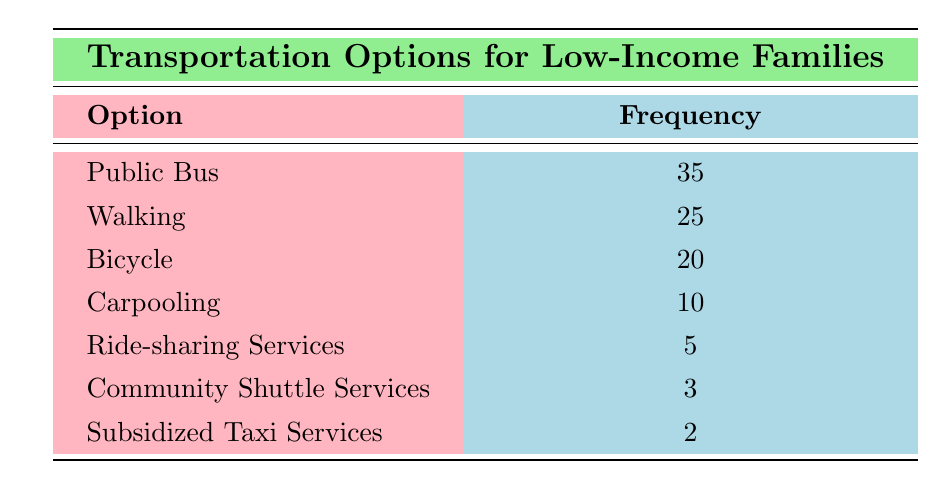What is the most common transportation option for low-income families? The table lists various transportation options along with their frequencies. The option with the highest frequency is "Public Bus," which has a frequency of 35.
Answer: Public Bus How many more families use bicycles than ride-sharing services? To find this, we look at the frequencies for "Bicycle" (20) and "Ride-sharing Services" (5). The difference is 20 - 5 = 15.
Answer: 15 Is the frequency of carpooling higher than that of community shuttle services? The frequency for "Carpooling" is 10, while for "Community Shuttle Services," it is 3. Since 10 is greater than 3, the statement is true.
Answer: Yes What is the total frequency of all transportation options listed? We sum the frequencies of all options: 35 (Public Bus) + 25 (Walking) + 20 (Bicycle) + 10 (Carpooling) + 5 (Ride-sharing Services) + 2 (Subsidized Taxi Services) + 3 (Community Shuttle Services) = 100.
Answer: 100 Which transportation option has the lowest frequency? By reviewing the table, the option with the lowest frequency is "Subsidized Taxi Services" with a frequency of 2.
Answer: Subsidized Taxi Services What is the average frequency of transportation options available? There are 7 transportation options listed, and their total frequency is 100. To find the average, we divide the total frequency by the number of options: 100 / 7 ≈ 14.29.
Answer: Approximately 14.29 Do more families prefer walking over using ride-sharing services? The frequency for "Walking" is 25, while for "Ride-sharing Services," it is 5. Since 25 is greater than 5, yes, more families prefer walking.
Answer: Yes If you combine the frequencies of carpooling and bicycle usage, how does it compare to public bus usage? The combined frequency of "Carpooling" (10) and "Bicycle" (20) is 10 + 20 = 30, which is less than the frequency of "Public Bus" (35).
Answer: Less than How many transportation options have a frequency of less than 10? We can see that "Ride-sharing Services" (5), "Community Shuttle Services" (3), and "Subsidized Taxi Services" (2) all have frequencies less than 10. That makes a total of 3 options.
Answer: 3 